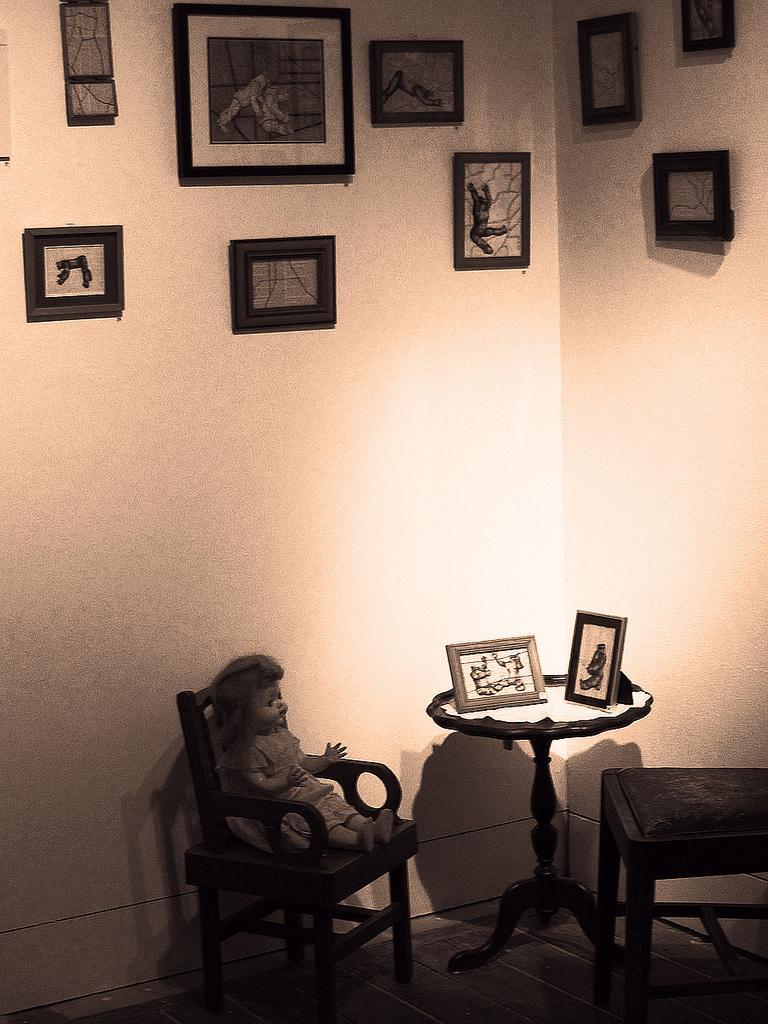Can you describe this image briefly? In this picture we can see two chairs and a table in the front, there is a doll on the chair, in the background there is a wall, we can see some photo frames on the wall, there are two photo frames on this table. 